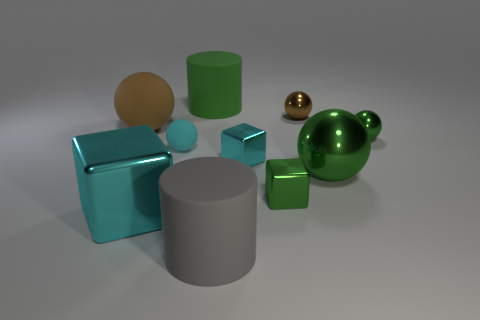Are the small cyan object that is on the left side of the large green cylinder and the large gray cylinder made of the same material? Based on the visual characteristics such as the surface finish and reflections, it appears that the small cyan object and the large gray cylinder could be made of similar materials, likely a type of metal or plastic with a matte finish. Both objects reflect light in a way that suggests they have a non-glossy surface, which is a common trait of matte finished materials. 